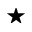Convert formula to latex. <formula><loc_0><loc_0><loc_500><loc_500>^ { * }</formula> 